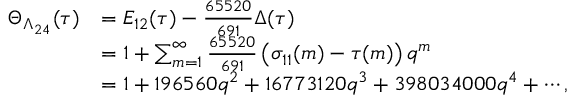<formula> <loc_0><loc_0><loc_500><loc_500>{ \begin{array} { r l } { \Theta _ { \Lambda _ { 2 4 } } ( \tau ) } & { = E _ { 1 2 } ( \tau ) - { \frac { 6 5 5 2 0 } { 6 9 1 } } \Delta ( \tau ) } \\ & { = 1 + \sum _ { m = 1 } ^ { \infty } { \frac { 6 5 5 2 0 } { 6 9 1 } } \left ( \sigma _ { 1 1 } ( m ) - \tau ( m ) \right ) q ^ { m } } \\ & { = 1 + 1 9 6 5 6 0 q ^ { 2 } + 1 6 7 7 3 1 2 0 q ^ { 3 } + 3 9 8 0 3 4 0 0 0 q ^ { 4 } + \cdots , } \end{array} }</formula> 